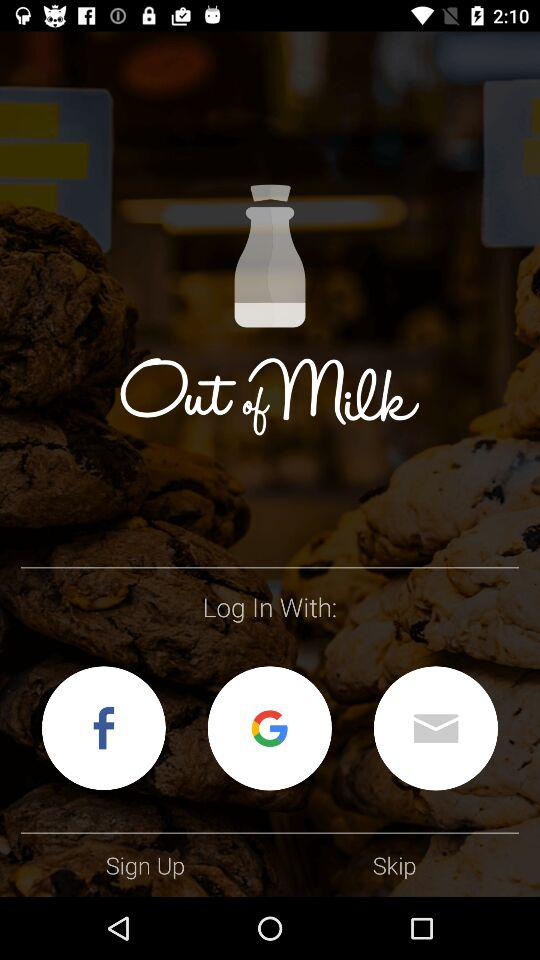Which applications can we use for logging in? You can use "Facebook" and "Google" for logging in. 